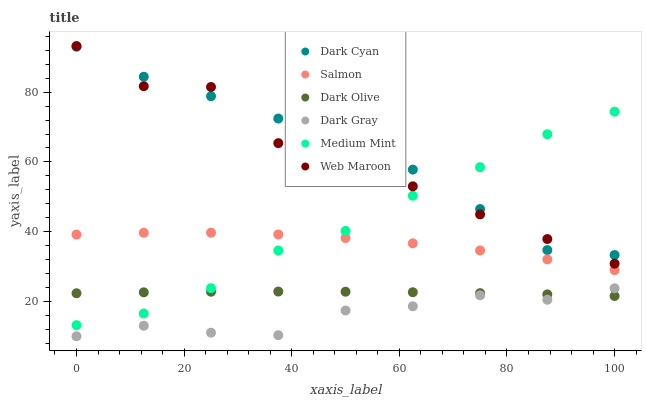Does Dark Gray have the minimum area under the curve?
Answer yes or no. Yes. Does Dark Cyan have the maximum area under the curve?
Answer yes or no. Yes. Does Web Maroon have the minimum area under the curve?
Answer yes or no. No. Does Web Maroon have the maximum area under the curve?
Answer yes or no. No. Is Dark Olive the smoothest?
Answer yes or no. Yes. Is Web Maroon the roughest?
Answer yes or no. Yes. Is Web Maroon the smoothest?
Answer yes or no. No. Is Dark Olive the roughest?
Answer yes or no. No. Does Dark Gray have the lowest value?
Answer yes or no. Yes. Does Web Maroon have the lowest value?
Answer yes or no. No. Does Web Maroon have the highest value?
Answer yes or no. Yes. Does Dark Olive have the highest value?
Answer yes or no. No. Is Dark Gray less than Salmon?
Answer yes or no. Yes. Is Web Maroon greater than Dark Gray?
Answer yes or no. Yes. Does Dark Olive intersect Dark Gray?
Answer yes or no. Yes. Is Dark Olive less than Dark Gray?
Answer yes or no. No. Is Dark Olive greater than Dark Gray?
Answer yes or no. No. Does Dark Gray intersect Salmon?
Answer yes or no. No. 